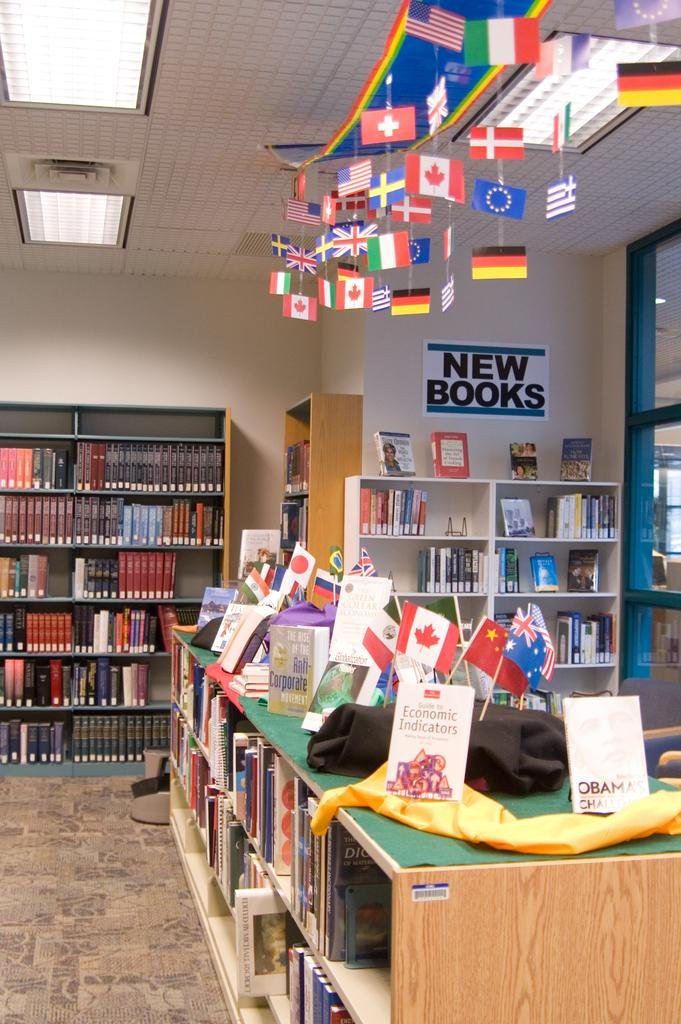<image>
Write a terse but informative summary of the picture. A shelf of books against the wall in a library under a sign that says New Books. 